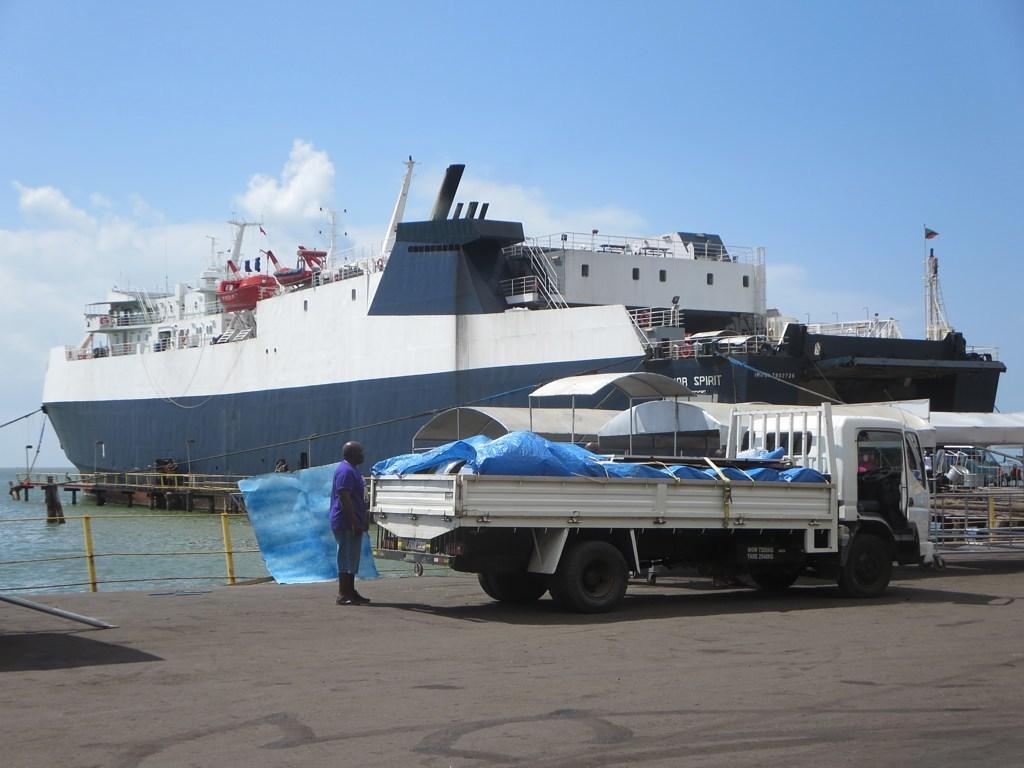In one or two sentences, can you explain what this image depicts? In this image we can see a person standing, a vehicle parked on the ground. In the center of the image we can see some sheds, a ship with some poles, railings and staircase is placed in the water. In the background, we can see a flag and the sky. 